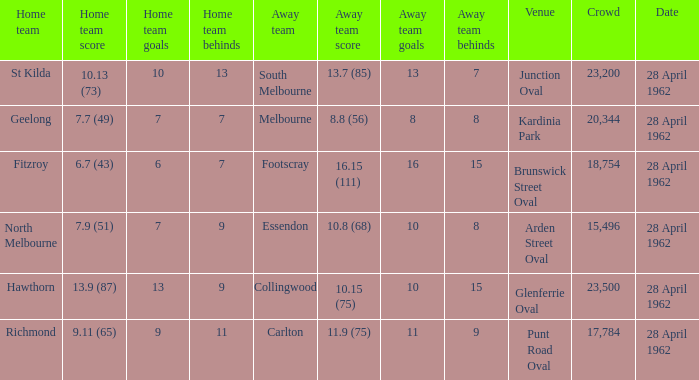At what venue did an away team score 10.15 (75)? Glenferrie Oval. 